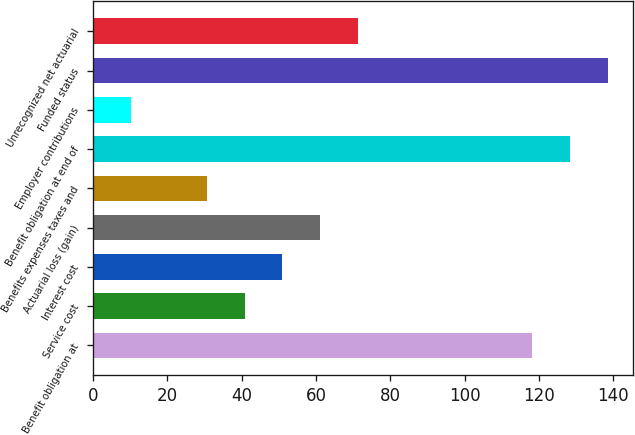<chart> <loc_0><loc_0><loc_500><loc_500><bar_chart><fcel>Benefit obligation at<fcel>Service cost<fcel>Interest cost<fcel>Actuarial loss (gain)<fcel>Benefits expenses taxes and<fcel>Benefit obligation at end of<fcel>Employer contributions<fcel>Funded status<fcel>Unrecognized net actuarial<nl><fcel>118.11<fcel>40.78<fcel>50.95<fcel>61.12<fcel>30.61<fcel>128.28<fcel>10.27<fcel>138.45<fcel>71.29<nl></chart> 